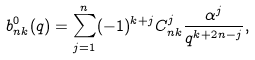Convert formula to latex. <formula><loc_0><loc_0><loc_500><loc_500>b _ { n k } ^ { 0 } ( q ) = \sum _ { j = 1 } ^ { n } ( - 1 ) ^ { k + j } C _ { n k } ^ { j } \frac { \alpha ^ { j } } { q ^ { k + 2 n - j } } ,</formula> 